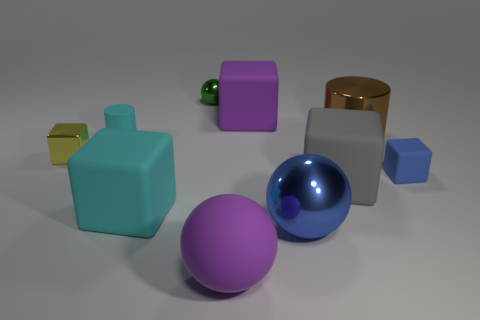Subtract 2 blocks. How many blocks are left? 3 Subtract all big gray cubes. How many cubes are left? 4 Subtract all cyan cubes. How many cubes are left? 4 Subtract all red cubes. Subtract all cyan balls. How many cubes are left? 5 Subtract all cylinders. How many objects are left? 8 Subtract all gray blocks. Subtract all big matte cubes. How many objects are left? 6 Add 8 small metal objects. How many small metal objects are left? 10 Add 3 brown objects. How many brown objects exist? 4 Subtract 0 green cylinders. How many objects are left? 10 